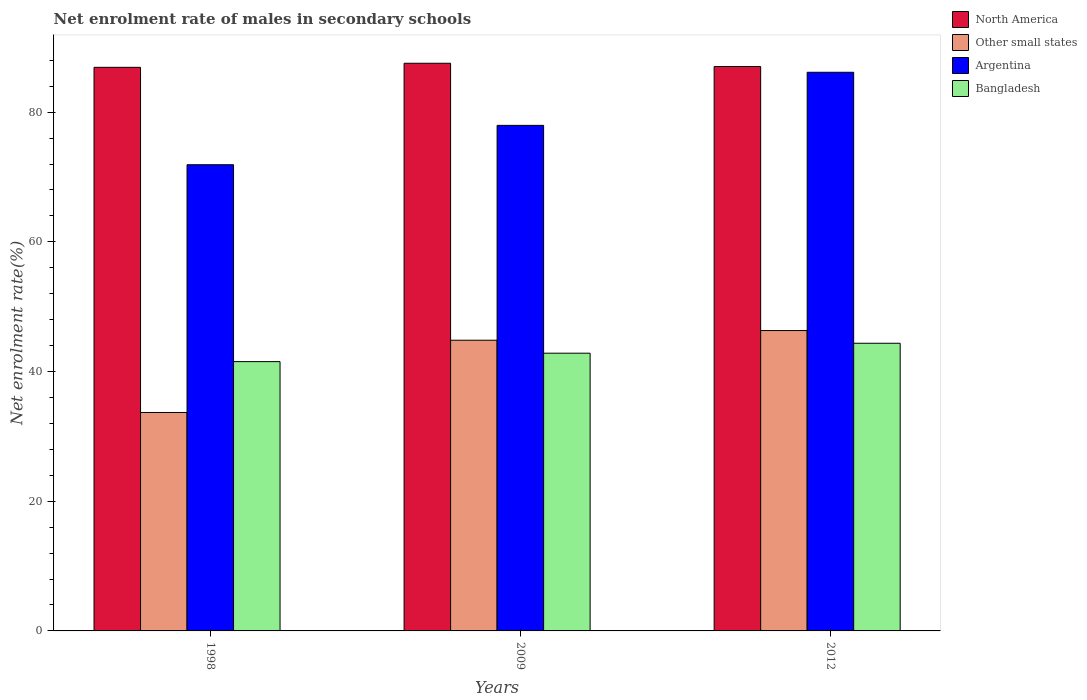How many groups of bars are there?
Give a very brief answer. 3. Are the number of bars on each tick of the X-axis equal?
Give a very brief answer. Yes. What is the net enrolment rate of males in secondary schools in Other small states in 2012?
Offer a terse response. 46.32. Across all years, what is the maximum net enrolment rate of males in secondary schools in North America?
Offer a terse response. 87.54. Across all years, what is the minimum net enrolment rate of males in secondary schools in Other small states?
Give a very brief answer. 33.68. In which year was the net enrolment rate of males in secondary schools in North America minimum?
Your answer should be compact. 1998. What is the total net enrolment rate of males in secondary schools in Bangladesh in the graph?
Your answer should be compact. 128.72. What is the difference between the net enrolment rate of males in secondary schools in Bangladesh in 1998 and that in 2009?
Your answer should be compact. -1.3. What is the difference between the net enrolment rate of males in secondary schools in Bangladesh in 1998 and the net enrolment rate of males in secondary schools in Argentina in 2012?
Make the answer very short. -44.62. What is the average net enrolment rate of males in secondary schools in North America per year?
Your response must be concise. 87.16. In the year 2009, what is the difference between the net enrolment rate of males in secondary schools in North America and net enrolment rate of males in secondary schools in Bangladesh?
Offer a very short reply. 44.71. What is the ratio of the net enrolment rate of males in secondary schools in Other small states in 2009 to that in 2012?
Give a very brief answer. 0.97. What is the difference between the highest and the second highest net enrolment rate of males in secondary schools in Other small states?
Make the answer very short. 1.49. What is the difference between the highest and the lowest net enrolment rate of males in secondary schools in Other small states?
Offer a terse response. 12.64. Is the sum of the net enrolment rate of males in secondary schools in Other small states in 1998 and 2009 greater than the maximum net enrolment rate of males in secondary schools in Argentina across all years?
Your answer should be very brief. No. Is it the case that in every year, the sum of the net enrolment rate of males in secondary schools in Argentina and net enrolment rate of males in secondary schools in North America is greater than the sum of net enrolment rate of males in secondary schools in Other small states and net enrolment rate of males in secondary schools in Bangladesh?
Make the answer very short. Yes. What does the 4th bar from the left in 2009 represents?
Your answer should be very brief. Bangladesh. Is it the case that in every year, the sum of the net enrolment rate of males in secondary schools in Argentina and net enrolment rate of males in secondary schools in North America is greater than the net enrolment rate of males in secondary schools in Bangladesh?
Ensure brevity in your answer.  Yes. How many bars are there?
Make the answer very short. 12. Are all the bars in the graph horizontal?
Keep it short and to the point. No. How many years are there in the graph?
Provide a short and direct response. 3. Does the graph contain grids?
Provide a short and direct response. No. What is the title of the graph?
Keep it short and to the point. Net enrolment rate of males in secondary schools. What is the label or title of the Y-axis?
Offer a terse response. Net enrolment rate(%). What is the Net enrolment rate(%) of North America in 1998?
Offer a very short reply. 86.91. What is the Net enrolment rate(%) in Other small states in 1998?
Your answer should be compact. 33.68. What is the Net enrolment rate(%) in Argentina in 1998?
Provide a succinct answer. 71.9. What is the Net enrolment rate(%) of Bangladesh in 1998?
Give a very brief answer. 41.53. What is the Net enrolment rate(%) in North America in 2009?
Offer a terse response. 87.54. What is the Net enrolment rate(%) in Other small states in 2009?
Ensure brevity in your answer.  44.83. What is the Net enrolment rate(%) in Argentina in 2009?
Provide a short and direct response. 77.97. What is the Net enrolment rate(%) of Bangladesh in 2009?
Make the answer very short. 42.83. What is the Net enrolment rate(%) in North America in 2012?
Provide a short and direct response. 87.04. What is the Net enrolment rate(%) of Other small states in 2012?
Provide a short and direct response. 46.32. What is the Net enrolment rate(%) of Argentina in 2012?
Your answer should be compact. 86.15. What is the Net enrolment rate(%) of Bangladesh in 2012?
Give a very brief answer. 44.36. Across all years, what is the maximum Net enrolment rate(%) in North America?
Offer a very short reply. 87.54. Across all years, what is the maximum Net enrolment rate(%) of Other small states?
Your answer should be compact. 46.32. Across all years, what is the maximum Net enrolment rate(%) in Argentina?
Make the answer very short. 86.15. Across all years, what is the maximum Net enrolment rate(%) in Bangladesh?
Your answer should be compact. 44.36. Across all years, what is the minimum Net enrolment rate(%) of North America?
Keep it short and to the point. 86.91. Across all years, what is the minimum Net enrolment rate(%) in Other small states?
Keep it short and to the point. 33.68. Across all years, what is the minimum Net enrolment rate(%) in Argentina?
Your answer should be very brief. 71.9. Across all years, what is the minimum Net enrolment rate(%) in Bangladesh?
Make the answer very short. 41.53. What is the total Net enrolment rate(%) in North America in the graph?
Your answer should be compact. 261.49. What is the total Net enrolment rate(%) of Other small states in the graph?
Offer a terse response. 124.84. What is the total Net enrolment rate(%) of Argentina in the graph?
Provide a short and direct response. 236.01. What is the total Net enrolment rate(%) in Bangladesh in the graph?
Give a very brief answer. 128.72. What is the difference between the Net enrolment rate(%) in North America in 1998 and that in 2009?
Give a very brief answer. -0.63. What is the difference between the Net enrolment rate(%) of Other small states in 1998 and that in 2009?
Offer a very short reply. -11.15. What is the difference between the Net enrolment rate(%) in Argentina in 1998 and that in 2009?
Offer a terse response. -6.07. What is the difference between the Net enrolment rate(%) in Bangladesh in 1998 and that in 2009?
Your response must be concise. -1.3. What is the difference between the Net enrolment rate(%) of North America in 1998 and that in 2012?
Keep it short and to the point. -0.12. What is the difference between the Net enrolment rate(%) of Other small states in 1998 and that in 2012?
Keep it short and to the point. -12.64. What is the difference between the Net enrolment rate(%) in Argentina in 1998 and that in 2012?
Ensure brevity in your answer.  -14.26. What is the difference between the Net enrolment rate(%) of Bangladesh in 1998 and that in 2012?
Provide a short and direct response. -2.83. What is the difference between the Net enrolment rate(%) in North America in 2009 and that in 2012?
Make the answer very short. 0.5. What is the difference between the Net enrolment rate(%) in Other small states in 2009 and that in 2012?
Make the answer very short. -1.49. What is the difference between the Net enrolment rate(%) of Argentina in 2009 and that in 2012?
Provide a short and direct response. -8.19. What is the difference between the Net enrolment rate(%) of Bangladesh in 2009 and that in 2012?
Give a very brief answer. -1.53. What is the difference between the Net enrolment rate(%) in North America in 1998 and the Net enrolment rate(%) in Other small states in 2009?
Give a very brief answer. 42.08. What is the difference between the Net enrolment rate(%) of North America in 1998 and the Net enrolment rate(%) of Argentina in 2009?
Your answer should be very brief. 8.95. What is the difference between the Net enrolment rate(%) of North America in 1998 and the Net enrolment rate(%) of Bangladesh in 2009?
Keep it short and to the point. 44.09. What is the difference between the Net enrolment rate(%) in Other small states in 1998 and the Net enrolment rate(%) in Argentina in 2009?
Your response must be concise. -44.28. What is the difference between the Net enrolment rate(%) of Other small states in 1998 and the Net enrolment rate(%) of Bangladesh in 2009?
Provide a short and direct response. -9.14. What is the difference between the Net enrolment rate(%) of Argentina in 1998 and the Net enrolment rate(%) of Bangladesh in 2009?
Your response must be concise. 29.07. What is the difference between the Net enrolment rate(%) in North America in 1998 and the Net enrolment rate(%) in Other small states in 2012?
Keep it short and to the point. 40.59. What is the difference between the Net enrolment rate(%) of North America in 1998 and the Net enrolment rate(%) of Argentina in 2012?
Provide a short and direct response. 0.76. What is the difference between the Net enrolment rate(%) of North America in 1998 and the Net enrolment rate(%) of Bangladesh in 2012?
Provide a succinct answer. 42.55. What is the difference between the Net enrolment rate(%) in Other small states in 1998 and the Net enrolment rate(%) in Argentina in 2012?
Ensure brevity in your answer.  -52.47. What is the difference between the Net enrolment rate(%) of Other small states in 1998 and the Net enrolment rate(%) of Bangladesh in 2012?
Keep it short and to the point. -10.68. What is the difference between the Net enrolment rate(%) of Argentina in 1998 and the Net enrolment rate(%) of Bangladesh in 2012?
Keep it short and to the point. 27.53. What is the difference between the Net enrolment rate(%) of North America in 2009 and the Net enrolment rate(%) of Other small states in 2012?
Make the answer very short. 41.22. What is the difference between the Net enrolment rate(%) in North America in 2009 and the Net enrolment rate(%) in Argentina in 2012?
Provide a succinct answer. 1.39. What is the difference between the Net enrolment rate(%) in North America in 2009 and the Net enrolment rate(%) in Bangladesh in 2012?
Provide a short and direct response. 43.18. What is the difference between the Net enrolment rate(%) of Other small states in 2009 and the Net enrolment rate(%) of Argentina in 2012?
Give a very brief answer. -41.32. What is the difference between the Net enrolment rate(%) of Other small states in 2009 and the Net enrolment rate(%) of Bangladesh in 2012?
Your response must be concise. 0.47. What is the difference between the Net enrolment rate(%) of Argentina in 2009 and the Net enrolment rate(%) of Bangladesh in 2012?
Your answer should be very brief. 33.6. What is the average Net enrolment rate(%) in North America per year?
Provide a short and direct response. 87.16. What is the average Net enrolment rate(%) of Other small states per year?
Offer a terse response. 41.61. What is the average Net enrolment rate(%) in Argentina per year?
Make the answer very short. 78.67. What is the average Net enrolment rate(%) of Bangladesh per year?
Ensure brevity in your answer.  42.91. In the year 1998, what is the difference between the Net enrolment rate(%) of North America and Net enrolment rate(%) of Other small states?
Keep it short and to the point. 53.23. In the year 1998, what is the difference between the Net enrolment rate(%) in North America and Net enrolment rate(%) in Argentina?
Offer a very short reply. 15.02. In the year 1998, what is the difference between the Net enrolment rate(%) in North America and Net enrolment rate(%) in Bangladesh?
Your response must be concise. 45.38. In the year 1998, what is the difference between the Net enrolment rate(%) of Other small states and Net enrolment rate(%) of Argentina?
Your response must be concise. -38.21. In the year 1998, what is the difference between the Net enrolment rate(%) of Other small states and Net enrolment rate(%) of Bangladesh?
Your answer should be compact. -7.85. In the year 1998, what is the difference between the Net enrolment rate(%) in Argentina and Net enrolment rate(%) in Bangladesh?
Give a very brief answer. 30.36. In the year 2009, what is the difference between the Net enrolment rate(%) of North America and Net enrolment rate(%) of Other small states?
Your response must be concise. 42.71. In the year 2009, what is the difference between the Net enrolment rate(%) in North America and Net enrolment rate(%) in Argentina?
Offer a terse response. 9.58. In the year 2009, what is the difference between the Net enrolment rate(%) in North America and Net enrolment rate(%) in Bangladesh?
Your answer should be very brief. 44.71. In the year 2009, what is the difference between the Net enrolment rate(%) in Other small states and Net enrolment rate(%) in Argentina?
Keep it short and to the point. -33.13. In the year 2009, what is the difference between the Net enrolment rate(%) of Other small states and Net enrolment rate(%) of Bangladesh?
Keep it short and to the point. 2. In the year 2009, what is the difference between the Net enrolment rate(%) in Argentina and Net enrolment rate(%) in Bangladesh?
Provide a succinct answer. 35.14. In the year 2012, what is the difference between the Net enrolment rate(%) in North America and Net enrolment rate(%) in Other small states?
Your answer should be compact. 40.72. In the year 2012, what is the difference between the Net enrolment rate(%) of North America and Net enrolment rate(%) of Argentina?
Provide a short and direct response. 0.89. In the year 2012, what is the difference between the Net enrolment rate(%) in North America and Net enrolment rate(%) in Bangladesh?
Provide a short and direct response. 42.68. In the year 2012, what is the difference between the Net enrolment rate(%) in Other small states and Net enrolment rate(%) in Argentina?
Provide a succinct answer. -39.83. In the year 2012, what is the difference between the Net enrolment rate(%) in Other small states and Net enrolment rate(%) in Bangladesh?
Ensure brevity in your answer.  1.96. In the year 2012, what is the difference between the Net enrolment rate(%) of Argentina and Net enrolment rate(%) of Bangladesh?
Your answer should be compact. 41.79. What is the ratio of the Net enrolment rate(%) in Other small states in 1998 to that in 2009?
Your answer should be very brief. 0.75. What is the ratio of the Net enrolment rate(%) of Argentina in 1998 to that in 2009?
Your answer should be very brief. 0.92. What is the ratio of the Net enrolment rate(%) in Bangladesh in 1998 to that in 2009?
Offer a terse response. 0.97. What is the ratio of the Net enrolment rate(%) of Other small states in 1998 to that in 2012?
Your answer should be very brief. 0.73. What is the ratio of the Net enrolment rate(%) in Argentina in 1998 to that in 2012?
Offer a terse response. 0.83. What is the ratio of the Net enrolment rate(%) of Bangladesh in 1998 to that in 2012?
Make the answer very short. 0.94. What is the ratio of the Net enrolment rate(%) in North America in 2009 to that in 2012?
Your response must be concise. 1.01. What is the ratio of the Net enrolment rate(%) of Other small states in 2009 to that in 2012?
Provide a short and direct response. 0.97. What is the ratio of the Net enrolment rate(%) in Argentina in 2009 to that in 2012?
Provide a short and direct response. 0.91. What is the ratio of the Net enrolment rate(%) in Bangladesh in 2009 to that in 2012?
Your response must be concise. 0.97. What is the difference between the highest and the second highest Net enrolment rate(%) of North America?
Your answer should be compact. 0.5. What is the difference between the highest and the second highest Net enrolment rate(%) in Other small states?
Offer a terse response. 1.49. What is the difference between the highest and the second highest Net enrolment rate(%) in Argentina?
Provide a short and direct response. 8.19. What is the difference between the highest and the second highest Net enrolment rate(%) of Bangladesh?
Your response must be concise. 1.53. What is the difference between the highest and the lowest Net enrolment rate(%) of North America?
Offer a very short reply. 0.63. What is the difference between the highest and the lowest Net enrolment rate(%) in Other small states?
Give a very brief answer. 12.64. What is the difference between the highest and the lowest Net enrolment rate(%) of Argentina?
Your answer should be very brief. 14.26. What is the difference between the highest and the lowest Net enrolment rate(%) of Bangladesh?
Give a very brief answer. 2.83. 